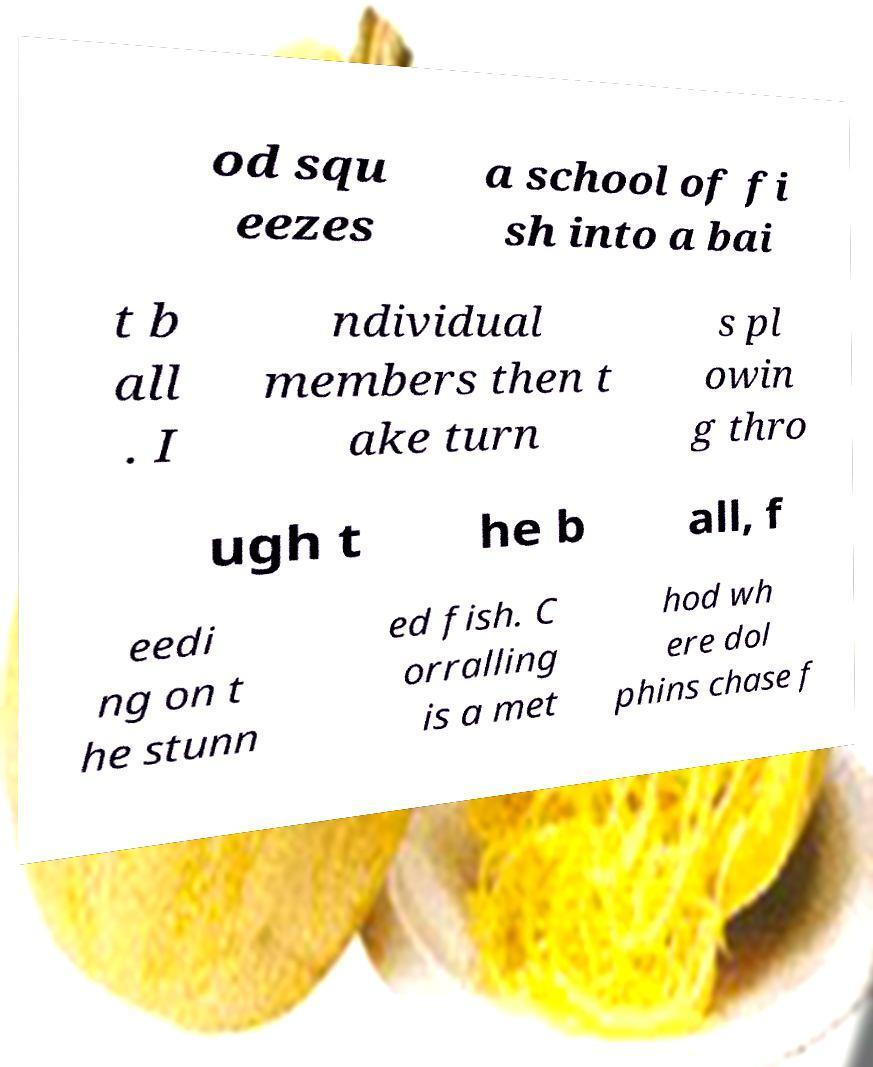For documentation purposes, I need the text within this image transcribed. Could you provide that? od squ eezes a school of fi sh into a bai t b all . I ndividual members then t ake turn s pl owin g thro ugh t he b all, f eedi ng on t he stunn ed fish. C orralling is a met hod wh ere dol phins chase f 